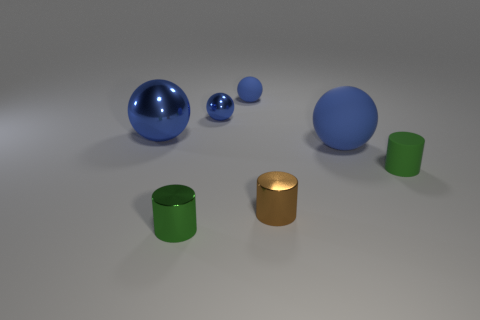Subtract 2 spheres. How many spheres are left? 2 Subtract all green cylinders. How many cylinders are left? 1 Subtract all green spheres. Subtract all blue cylinders. How many spheres are left? 4 Add 1 small green things. How many objects exist? 8 Subtract all spheres. How many objects are left? 3 Add 1 gray rubber balls. How many gray rubber balls exist? 1 Subtract 0 purple blocks. How many objects are left? 7 Subtract all large blue objects. Subtract all green shiny cylinders. How many objects are left? 4 Add 4 tiny blue metal spheres. How many tiny blue metal spheres are left? 5 